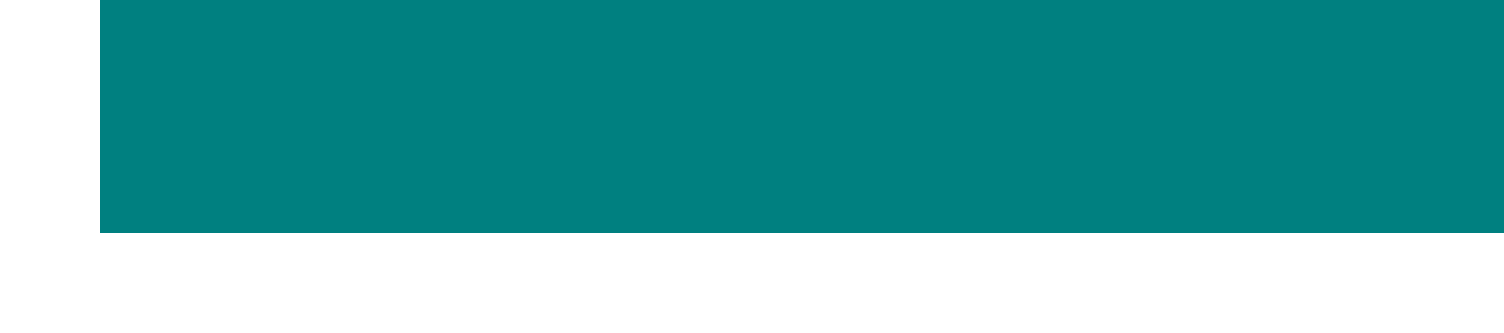What is the name of the software? The document introduces a new meal planning software called NutriSync Pro.
Answer: NutriSync Pro How many recipes are in the database? The document mentions that there is an extensive database of over 10,000 recipes.
Answer: 10,000 What is the special offer available? The email states a special offer of a 30-day free trial and 20% off the first year subscription.
Answer: 30-day free trial and 20% off Who provided the testimonial? The testimonial in the document is given by Sarah Johnson, Head Dietitian at FitLife Gym.
Answer: Sarah Johnson What fitness trackers does NutriSync Pro integrate with? The email specifies integration with popular fitness trackers like Fitbit and Garmin.
Answer: Fitbit and Garmin What benefit is associated with tracking progress? The document suggests that tracking progress helps make data-driven adjustments to meal plans.
Answer: Data-driven adjustments What is the document type? The document is a promotional email for a new product, specifically a meal planning software.
Answer: Promotional email What can users do on the website mentioned? The document suggests users can schedule a demo and start a free trial on the website.
Answer: Schedule a demo and start a free trial 